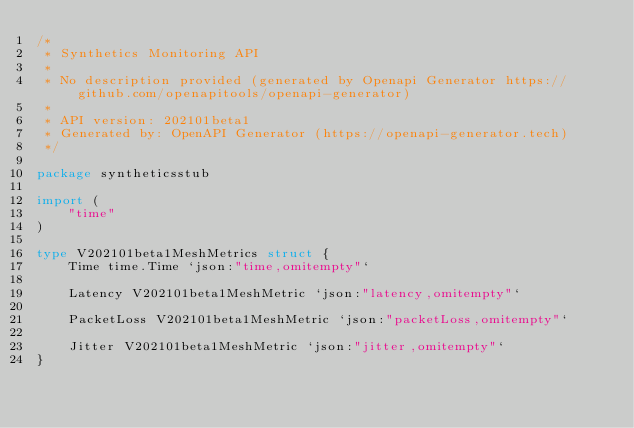Convert code to text. <code><loc_0><loc_0><loc_500><loc_500><_Go_>/*
 * Synthetics Monitoring API
 *
 * No description provided (generated by Openapi Generator https://github.com/openapitools/openapi-generator)
 *
 * API version: 202101beta1
 * Generated by: OpenAPI Generator (https://openapi-generator.tech)
 */

package syntheticsstub

import (
	"time"
)

type V202101beta1MeshMetrics struct {
	Time time.Time `json:"time,omitempty"`

	Latency V202101beta1MeshMetric `json:"latency,omitempty"`

	PacketLoss V202101beta1MeshMetric `json:"packetLoss,omitempty"`

	Jitter V202101beta1MeshMetric `json:"jitter,omitempty"`
}
</code> 